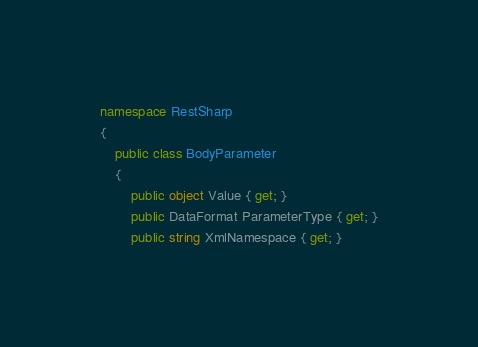Convert code to text. <code><loc_0><loc_0><loc_500><loc_500><_C#_>namespace RestSharp
{
    public class BodyParameter
    {
        public object Value { get; }
        public DataFormat ParameterType { get; }
        public string XmlNamespace { get; }
</code> 